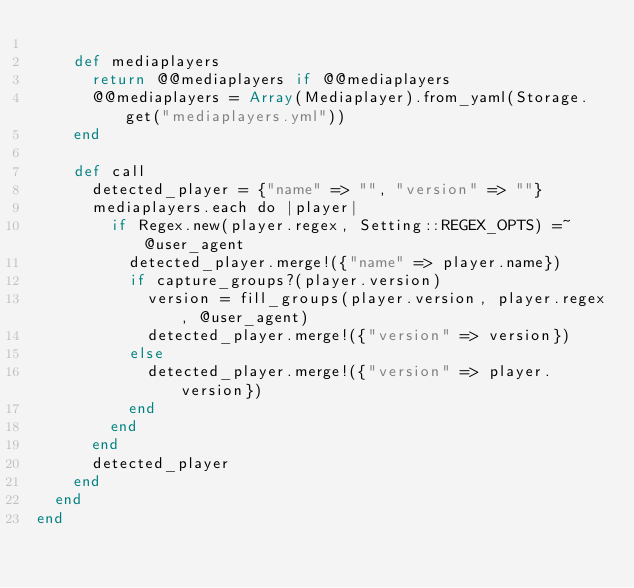<code> <loc_0><loc_0><loc_500><loc_500><_Crystal_>
    def mediaplayers
      return @@mediaplayers if @@mediaplayers
      @@mediaplayers = Array(Mediaplayer).from_yaml(Storage.get("mediaplayers.yml"))
    end

    def call
      detected_player = {"name" => "", "version" => ""}
      mediaplayers.each do |player|
        if Regex.new(player.regex, Setting::REGEX_OPTS) =~ @user_agent
          detected_player.merge!({"name" => player.name})
          if capture_groups?(player.version)
            version = fill_groups(player.version, player.regex, @user_agent)
            detected_player.merge!({"version" => version})
          else
            detected_player.merge!({"version" => player.version})
          end
        end
      end
      detected_player
    end
  end
end
</code> 